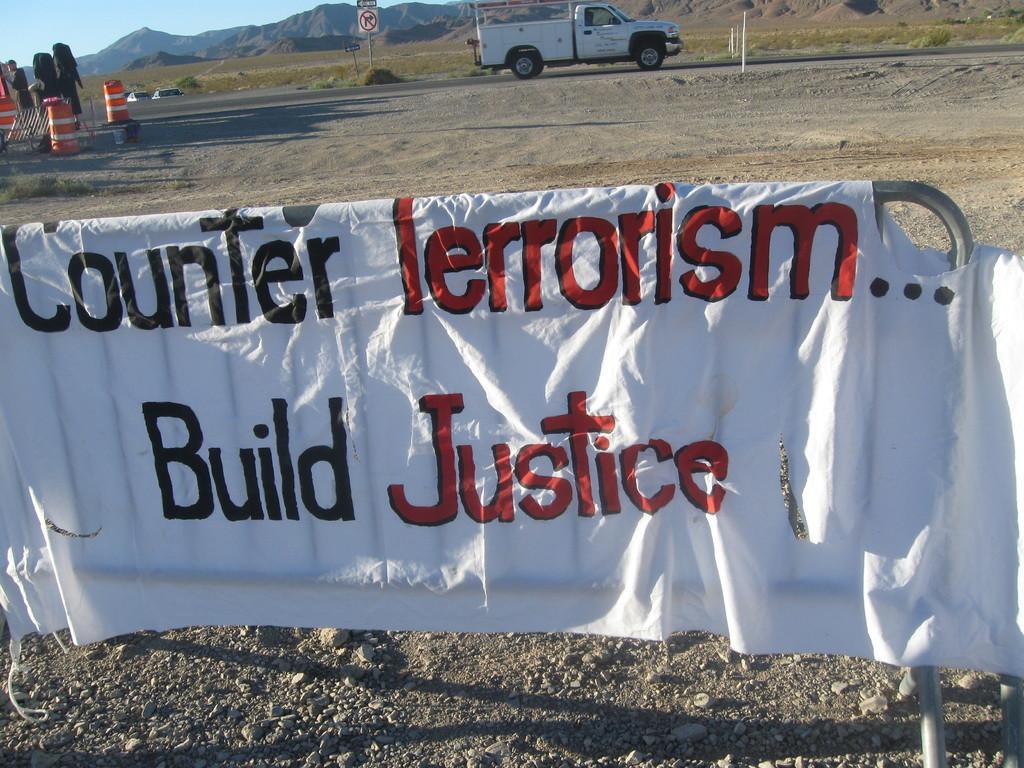How would you summarize this image in a sentence or two? Here in this picture, in the front we can see a cloth with something written on it hanging on the barricade, which is present on the ground and behind that in the far we can see a truck present and we can also see a sign board present on the ground and on the left side we can see drums present on the ground and we can see some part of ground is covered with grass and in the far we can see mountains present and we can see the sky is clear. 